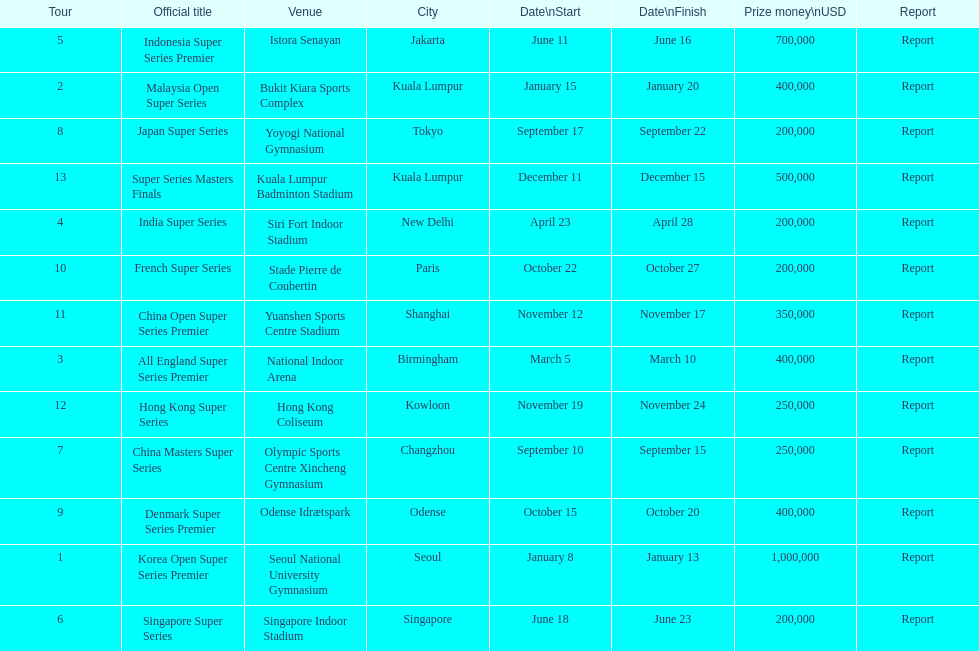Which has the same prize money as the french super series? Japan Super Series, Singapore Super Series, India Super Series. 